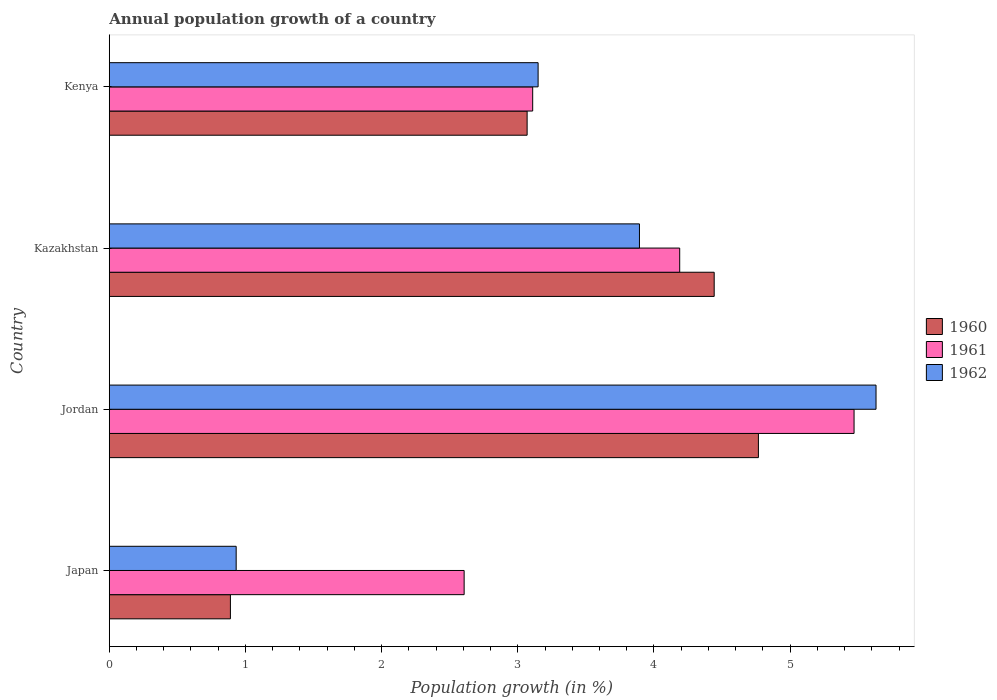How many different coloured bars are there?
Your answer should be very brief. 3. Are the number of bars per tick equal to the number of legend labels?
Offer a very short reply. Yes. Are the number of bars on each tick of the Y-axis equal?
Provide a short and direct response. Yes. How many bars are there on the 3rd tick from the top?
Ensure brevity in your answer.  3. How many bars are there on the 4th tick from the bottom?
Provide a succinct answer. 3. What is the label of the 4th group of bars from the top?
Make the answer very short. Japan. What is the annual population growth in 1961 in Japan?
Your answer should be very brief. 2.61. Across all countries, what is the maximum annual population growth in 1962?
Offer a terse response. 5.63. Across all countries, what is the minimum annual population growth in 1961?
Ensure brevity in your answer.  2.61. In which country was the annual population growth in 1960 maximum?
Your response must be concise. Jordan. In which country was the annual population growth in 1962 minimum?
Offer a terse response. Japan. What is the total annual population growth in 1960 in the graph?
Give a very brief answer. 13.17. What is the difference between the annual population growth in 1960 in Jordan and that in Kazakhstan?
Your response must be concise. 0.32. What is the difference between the annual population growth in 1962 in Japan and the annual population growth in 1960 in Kazakhstan?
Give a very brief answer. -3.51. What is the average annual population growth in 1960 per country?
Offer a very short reply. 3.29. What is the difference between the annual population growth in 1960 and annual population growth in 1962 in Kazakhstan?
Provide a succinct answer. 0.55. In how many countries, is the annual population growth in 1961 greater than 1.8 %?
Offer a very short reply. 4. What is the ratio of the annual population growth in 1962 in Japan to that in Jordan?
Keep it short and to the point. 0.17. What is the difference between the highest and the second highest annual population growth in 1962?
Provide a short and direct response. 1.74. What is the difference between the highest and the lowest annual population growth in 1960?
Make the answer very short. 3.88. Is the sum of the annual population growth in 1962 in Japan and Jordan greater than the maximum annual population growth in 1960 across all countries?
Offer a very short reply. Yes. What does the 2nd bar from the top in Kazakhstan represents?
Offer a very short reply. 1961. Is it the case that in every country, the sum of the annual population growth in 1961 and annual population growth in 1962 is greater than the annual population growth in 1960?
Give a very brief answer. Yes. Are the values on the major ticks of X-axis written in scientific E-notation?
Provide a short and direct response. No. How many legend labels are there?
Your response must be concise. 3. How are the legend labels stacked?
Provide a succinct answer. Vertical. What is the title of the graph?
Provide a short and direct response. Annual population growth of a country. Does "2005" appear as one of the legend labels in the graph?
Offer a terse response. No. What is the label or title of the X-axis?
Provide a short and direct response. Population growth (in %). What is the label or title of the Y-axis?
Your answer should be compact. Country. What is the Population growth (in %) in 1960 in Japan?
Offer a very short reply. 0.89. What is the Population growth (in %) in 1961 in Japan?
Offer a terse response. 2.61. What is the Population growth (in %) of 1962 in Japan?
Keep it short and to the point. 0.93. What is the Population growth (in %) of 1960 in Jordan?
Your response must be concise. 4.77. What is the Population growth (in %) of 1961 in Jordan?
Offer a terse response. 5.47. What is the Population growth (in %) in 1962 in Jordan?
Offer a terse response. 5.63. What is the Population growth (in %) of 1960 in Kazakhstan?
Make the answer very short. 4.44. What is the Population growth (in %) in 1961 in Kazakhstan?
Ensure brevity in your answer.  4.19. What is the Population growth (in %) in 1962 in Kazakhstan?
Provide a succinct answer. 3.89. What is the Population growth (in %) in 1960 in Kenya?
Make the answer very short. 3.07. What is the Population growth (in %) of 1961 in Kenya?
Your answer should be very brief. 3.11. What is the Population growth (in %) of 1962 in Kenya?
Ensure brevity in your answer.  3.15. Across all countries, what is the maximum Population growth (in %) of 1960?
Provide a short and direct response. 4.77. Across all countries, what is the maximum Population growth (in %) of 1961?
Offer a terse response. 5.47. Across all countries, what is the maximum Population growth (in %) of 1962?
Ensure brevity in your answer.  5.63. Across all countries, what is the minimum Population growth (in %) of 1960?
Your response must be concise. 0.89. Across all countries, what is the minimum Population growth (in %) of 1961?
Give a very brief answer. 2.61. Across all countries, what is the minimum Population growth (in %) in 1962?
Your answer should be compact. 0.93. What is the total Population growth (in %) of 1960 in the graph?
Your response must be concise. 13.17. What is the total Population growth (in %) in 1961 in the graph?
Your answer should be compact. 15.37. What is the total Population growth (in %) of 1962 in the graph?
Offer a very short reply. 13.61. What is the difference between the Population growth (in %) in 1960 in Japan and that in Jordan?
Offer a very short reply. -3.88. What is the difference between the Population growth (in %) in 1961 in Japan and that in Jordan?
Offer a terse response. -2.86. What is the difference between the Population growth (in %) in 1962 in Japan and that in Jordan?
Your answer should be compact. -4.7. What is the difference between the Population growth (in %) of 1960 in Japan and that in Kazakhstan?
Ensure brevity in your answer.  -3.55. What is the difference between the Population growth (in %) of 1961 in Japan and that in Kazakhstan?
Offer a very short reply. -1.58. What is the difference between the Population growth (in %) of 1962 in Japan and that in Kazakhstan?
Your response must be concise. -2.96. What is the difference between the Population growth (in %) in 1960 in Japan and that in Kenya?
Provide a succinct answer. -2.18. What is the difference between the Population growth (in %) of 1961 in Japan and that in Kenya?
Ensure brevity in your answer.  -0.5. What is the difference between the Population growth (in %) in 1962 in Japan and that in Kenya?
Keep it short and to the point. -2.22. What is the difference between the Population growth (in %) in 1960 in Jordan and that in Kazakhstan?
Make the answer very short. 0.32. What is the difference between the Population growth (in %) of 1961 in Jordan and that in Kazakhstan?
Your response must be concise. 1.28. What is the difference between the Population growth (in %) in 1962 in Jordan and that in Kazakhstan?
Make the answer very short. 1.74. What is the difference between the Population growth (in %) in 1960 in Jordan and that in Kenya?
Make the answer very short. 1.7. What is the difference between the Population growth (in %) of 1961 in Jordan and that in Kenya?
Give a very brief answer. 2.36. What is the difference between the Population growth (in %) in 1962 in Jordan and that in Kenya?
Provide a short and direct response. 2.48. What is the difference between the Population growth (in %) of 1960 in Kazakhstan and that in Kenya?
Give a very brief answer. 1.37. What is the difference between the Population growth (in %) in 1961 in Kazakhstan and that in Kenya?
Your answer should be very brief. 1.08. What is the difference between the Population growth (in %) in 1962 in Kazakhstan and that in Kenya?
Provide a succinct answer. 0.74. What is the difference between the Population growth (in %) of 1960 in Japan and the Population growth (in %) of 1961 in Jordan?
Your answer should be very brief. -4.58. What is the difference between the Population growth (in %) of 1960 in Japan and the Population growth (in %) of 1962 in Jordan?
Give a very brief answer. -4.74. What is the difference between the Population growth (in %) in 1961 in Japan and the Population growth (in %) in 1962 in Jordan?
Your answer should be compact. -3.02. What is the difference between the Population growth (in %) of 1960 in Japan and the Population growth (in %) of 1961 in Kazakhstan?
Keep it short and to the point. -3.3. What is the difference between the Population growth (in %) of 1960 in Japan and the Population growth (in %) of 1962 in Kazakhstan?
Ensure brevity in your answer.  -3. What is the difference between the Population growth (in %) of 1961 in Japan and the Population growth (in %) of 1962 in Kazakhstan?
Keep it short and to the point. -1.29. What is the difference between the Population growth (in %) of 1960 in Japan and the Population growth (in %) of 1961 in Kenya?
Keep it short and to the point. -2.22. What is the difference between the Population growth (in %) in 1960 in Japan and the Population growth (in %) in 1962 in Kenya?
Your response must be concise. -2.26. What is the difference between the Population growth (in %) in 1961 in Japan and the Population growth (in %) in 1962 in Kenya?
Your answer should be compact. -0.54. What is the difference between the Population growth (in %) of 1960 in Jordan and the Population growth (in %) of 1961 in Kazakhstan?
Provide a short and direct response. 0.58. What is the difference between the Population growth (in %) of 1960 in Jordan and the Population growth (in %) of 1962 in Kazakhstan?
Offer a terse response. 0.87. What is the difference between the Population growth (in %) of 1961 in Jordan and the Population growth (in %) of 1962 in Kazakhstan?
Give a very brief answer. 1.58. What is the difference between the Population growth (in %) in 1960 in Jordan and the Population growth (in %) in 1961 in Kenya?
Give a very brief answer. 1.66. What is the difference between the Population growth (in %) in 1960 in Jordan and the Population growth (in %) in 1962 in Kenya?
Offer a very short reply. 1.62. What is the difference between the Population growth (in %) of 1961 in Jordan and the Population growth (in %) of 1962 in Kenya?
Provide a short and direct response. 2.32. What is the difference between the Population growth (in %) of 1960 in Kazakhstan and the Population growth (in %) of 1961 in Kenya?
Offer a very short reply. 1.33. What is the difference between the Population growth (in %) of 1960 in Kazakhstan and the Population growth (in %) of 1962 in Kenya?
Provide a short and direct response. 1.29. What is the difference between the Population growth (in %) of 1961 in Kazakhstan and the Population growth (in %) of 1962 in Kenya?
Give a very brief answer. 1.04. What is the average Population growth (in %) of 1960 per country?
Provide a short and direct response. 3.29. What is the average Population growth (in %) of 1961 per country?
Keep it short and to the point. 3.84. What is the average Population growth (in %) of 1962 per country?
Your response must be concise. 3.4. What is the difference between the Population growth (in %) of 1960 and Population growth (in %) of 1961 in Japan?
Your answer should be very brief. -1.72. What is the difference between the Population growth (in %) of 1960 and Population growth (in %) of 1962 in Japan?
Ensure brevity in your answer.  -0.04. What is the difference between the Population growth (in %) of 1961 and Population growth (in %) of 1962 in Japan?
Give a very brief answer. 1.67. What is the difference between the Population growth (in %) of 1960 and Population growth (in %) of 1961 in Jordan?
Keep it short and to the point. -0.7. What is the difference between the Population growth (in %) in 1960 and Population growth (in %) in 1962 in Jordan?
Offer a terse response. -0.86. What is the difference between the Population growth (in %) of 1961 and Population growth (in %) of 1962 in Jordan?
Offer a terse response. -0.16. What is the difference between the Population growth (in %) of 1960 and Population growth (in %) of 1961 in Kazakhstan?
Offer a terse response. 0.25. What is the difference between the Population growth (in %) in 1960 and Population growth (in %) in 1962 in Kazakhstan?
Your answer should be very brief. 0.55. What is the difference between the Population growth (in %) in 1961 and Population growth (in %) in 1962 in Kazakhstan?
Give a very brief answer. 0.3. What is the difference between the Population growth (in %) of 1960 and Population growth (in %) of 1961 in Kenya?
Give a very brief answer. -0.04. What is the difference between the Population growth (in %) of 1960 and Population growth (in %) of 1962 in Kenya?
Your answer should be compact. -0.08. What is the difference between the Population growth (in %) of 1961 and Population growth (in %) of 1962 in Kenya?
Provide a succinct answer. -0.04. What is the ratio of the Population growth (in %) in 1960 in Japan to that in Jordan?
Your response must be concise. 0.19. What is the ratio of the Population growth (in %) of 1961 in Japan to that in Jordan?
Give a very brief answer. 0.48. What is the ratio of the Population growth (in %) in 1962 in Japan to that in Jordan?
Keep it short and to the point. 0.17. What is the ratio of the Population growth (in %) of 1960 in Japan to that in Kazakhstan?
Offer a terse response. 0.2. What is the ratio of the Population growth (in %) in 1961 in Japan to that in Kazakhstan?
Your answer should be very brief. 0.62. What is the ratio of the Population growth (in %) of 1962 in Japan to that in Kazakhstan?
Make the answer very short. 0.24. What is the ratio of the Population growth (in %) of 1960 in Japan to that in Kenya?
Offer a terse response. 0.29. What is the ratio of the Population growth (in %) of 1961 in Japan to that in Kenya?
Provide a short and direct response. 0.84. What is the ratio of the Population growth (in %) in 1962 in Japan to that in Kenya?
Your answer should be very brief. 0.3. What is the ratio of the Population growth (in %) in 1960 in Jordan to that in Kazakhstan?
Offer a terse response. 1.07. What is the ratio of the Population growth (in %) in 1961 in Jordan to that in Kazakhstan?
Give a very brief answer. 1.31. What is the ratio of the Population growth (in %) in 1962 in Jordan to that in Kazakhstan?
Your answer should be compact. 1.45. What is the ratio of the Population growth (in %) of 1960 in Jordan to that in Kenya?
Give a very brief answer. 1.55. What is the ratio of the Population growth (in %) of 1961 in Jordan to that in Kenya?
Your answer should be very brief. 1.76. What is the ratio of the Population growth (in %) of 1962 in Jordan to that in Kenya?
Offer a terse response. 1.79. What is the ratio of the Population growth (in %) of 1960 in Kazakhstan to that in Kenya?
Your answer should be very brief. 1.45. What is the ratio of the Population growth (in %) of 1961 in Kazakhstan to that in Kenya?
Ensure brevity in your answer.  1.35. What is the ratio of the Population growth (in %) of 1962 in Kazakhstan to that in Kenya?
Provide a succinct answer. 1.24. What is the difference between the highest and the second highest Population growth (in %) of 1960?
Keep it short and to the point. 0.32. What is the difference between the highest and the second highest Population growth (in %) in 1961?
Make the answer very short. 1.28. What is the difference between the highest and the second highest Population growth (in %) of 1962?
Offer a terse response. 1.74. What is the difference between the highest and the lowest Population growth (in %) in 1960?
Offer a very short reply. 3.88. What is the difference between the highest and the lowest Population growth (in %) of 1961?
Ensure brevity in your answer.  2.86. What is the difference between the highest and the lowest Population growth (in %) of 1962?
Ensure brevity in your answer.  4.7. 